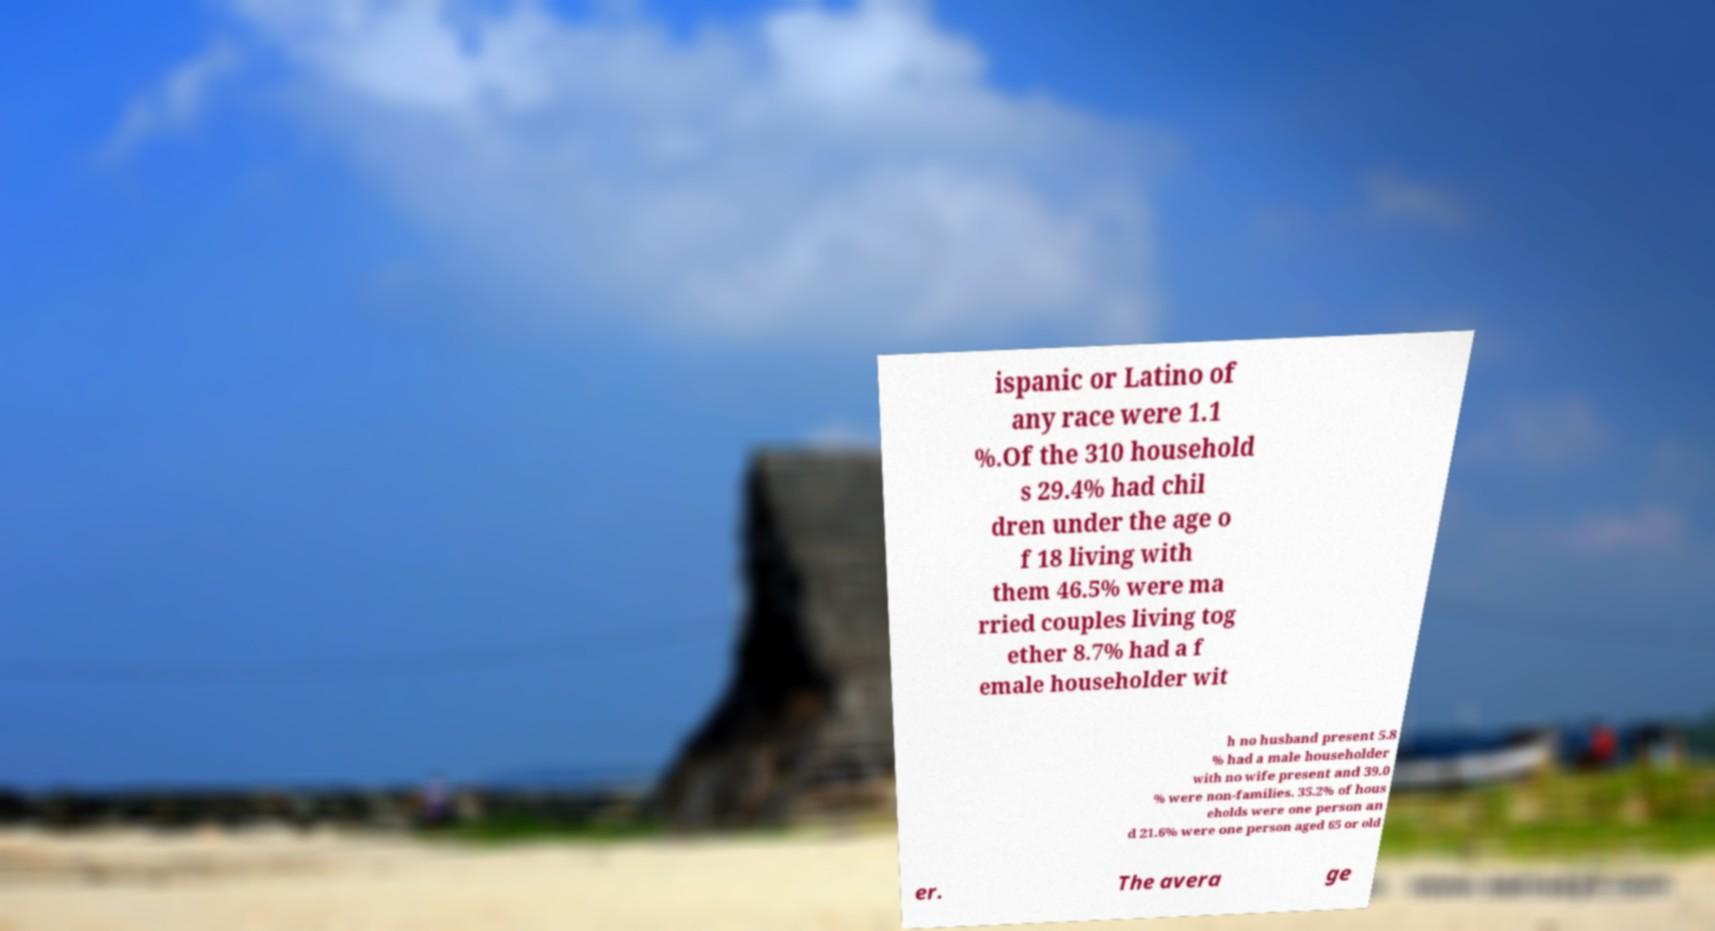Please read and relay the text visible in this image. What does it say? ispanic or Latino of any race were 1.1 %.Of the 310 household s 29.4% had chil dren under the age o f 18 living with them 46.5% were ma rried couples living tog ether 8.7% had a f emale householder wit h no husband present 5.8 % had a male householder with no wife present and 39.0 % were non-families. 35.2% of hous eholds were one person an d 21.6% were one person aged 65 or old er. The avera ge 